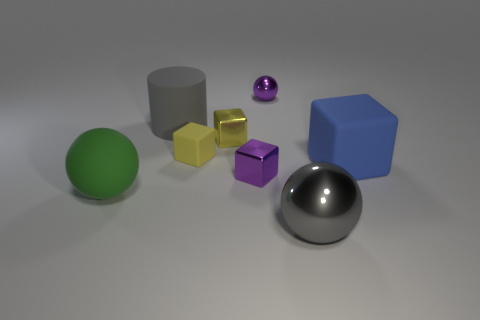There is a big ball in front of the matte thing in front of the large matte thing on the right side of the big gray metal object; what is it made of?
Your response must be concise. Metal. What is the material of the other block that is the same color as the tiny matte block?
Give a very brief answer. Metal. There is a shiny object in front of the big green object; is its color the same as the cylinder?
Ensure brevity in your answer.  Yes. What size is the green rubber ball?
Give a very brief answer. Large. Does the large shiny sphere have the same color as the large rubber object that is behind the blue rubber object?
Your answer should be very brief. Yes. Are there fewer yellow shiny things that are in front of the small purple shiny cube than purple metallic blocks?
Offer a very short reply. Yes. Do the tiny purple sphere and the large gray cylinder have the same material?
Give a very brief answer. No. What size is the other rubber thing that is the same shape as the large blue matte thing?
Ensure brevity in your answer.  Small. How many things are either big things that are in front of the matte ball or big matte objects that are left of the big gray rubber cylinder?
Your response must be concise. 2. Are there fewer blue objects than metallic balls?
Ensure brevity in your answer.  Yes. 